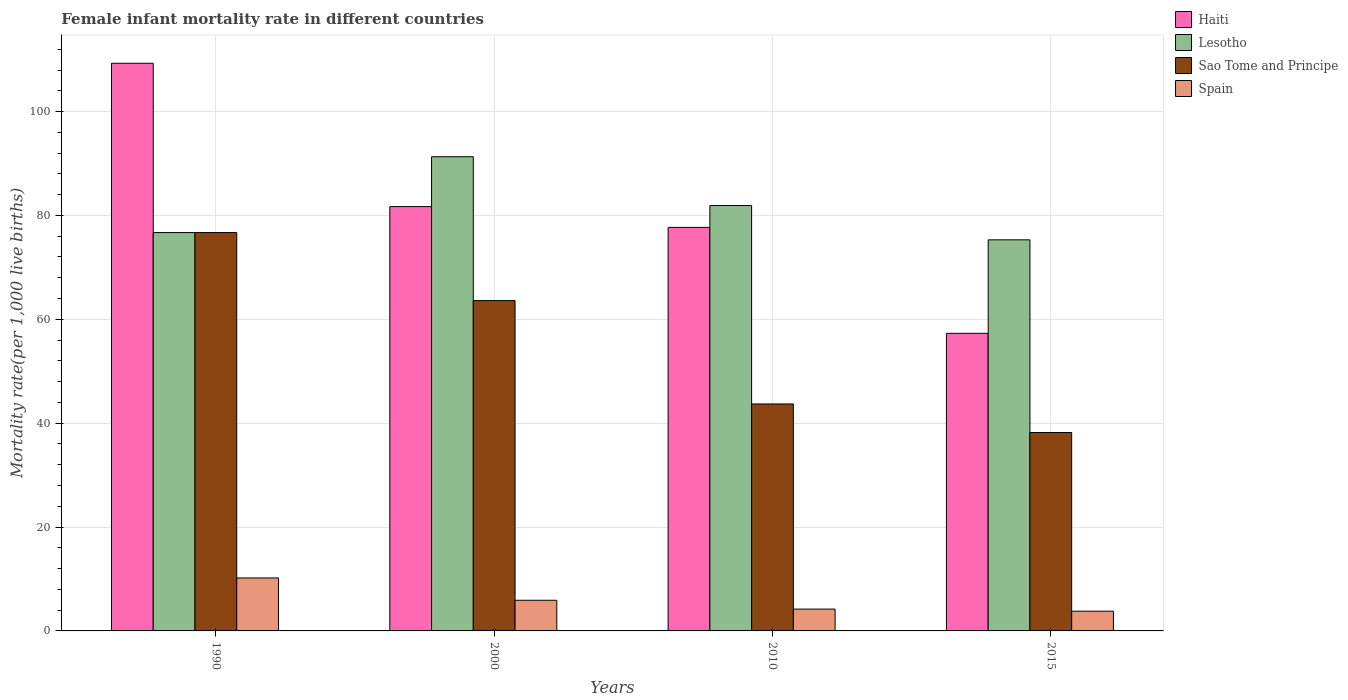How many different coloured bars are there?
Make the answer very short. 4. Are the number of bars on each tick of the X-axis equal?
Provide a succinct answer. Yes. In how many cases, is the number of bars for a given year not equal to the number of legend labels?
Provide a short and direct response. 0. What is the female infant mortality rate in Spain in 2000?
Your answer should be compact. 5.9. Across all years, what is the maximum female infant mortality rate in Haiti?
Offer a terse response. 109.3. Across all years, what is the minimum female infant mortality rate in Spain?
Provide a succinct answer. 3.8. In which year was the female infant mortality rate in Sao Tome and Principe maximum?
Keep it short and to the point. 1990. In which year was the female infant mortality rate in Lesotho minimum?
Provide a short and direct response. 2015. What is the total female infant mortality rate in Lesotho in the graph?
Offer a very short reply. 325.2. What is the difference between the female infant mortality rate in Lesotho in 2000 and that in 2015?
Offer a very short reply. 16. What is the difference between the female infant mortality rate in Spain in 2010 and the female infant mortality rate in Sao Tome and Principe in 2015?
Make the answer very short. -34. What is the average female infant mortality rate in Sao Tome and Principe per year?
Ensure brevity in your answer.  55.55. In the year 2000, what is the difference between the female infant mortality rate in Lesotho and female infant mortality rate in Spain?
Your response must be concise. 85.4. In how many years, is the female infant mortality rate in Spain greater than 60?
Provide a short and direct response. 0. What is the ratio of the female infant mortality rate in Haiti in 1990 to that in 2000?
Your response must be concise. 1.34. Is the difference between the female infant mortality rate in Lesotho in 1990 and 2010 greater than the difference between the female infant mortality rate in Spain in 1990 and 2010?
Your answer should be very brief. No. What is the difference between the highest and the second highest female infant mortality rate in Haiti?
Offer a terse response. 27.6. What is the difference between the highest and the lowest female infant mortality rate in Sao Tome and Principe?
Your response must be concise. 38.5. In how many years, is the female infant mortality rate in Sao Tome and Principe greater than the average female infant mortality rate in Sao Tome and Principe taken over all years?
Your response must be concise. 2. Is the sum of the female infant mortality rate in Haiti in 2000 and 2010 greater than the maximum female infant mortality rate in Sao Tome and Principe across all years?
Give a very brief answer. Yes. Is it the case that in every year, the sum of the female infant mortality rate in Spain and female infant mortality rate in Haiti is greater than the sum of female infant mortality rate in Sao Tome and Principe and female infant mortality rate in Lesotho?
Your answer should be very brief. Yes. What does the 3rd bar from the left in 2000 represents?
Offer a terse response. Sao Tome and Principe. What does the 2nd bar from the right in 2015 represents?
Ensure brevity in your answer.  Sao Tome and Principe. Are all the bars in the graph horizontal?
Provide a succinct answer. No. What is the difference between two consecutive major ticks on the Y-axis?
Your answer should be compact. 20. Does the graph contain grids?
Offer a very short reply. Yes. Where does the legend appear in the graph?
Offer a terse response. Top right. How many legend labels are there?
Keep it short and to the point. 4. How are the legend labels stacked?
Offer a terse response. Vertical. What is the title of the graph?
Provide a succinct answer. Female infant mortality rate in different countries. What is the label or title of the Y-axis?
Keep it short and to the point. Mortality rate(per 1,0 live births). What is the Mortality rate(per 1,000 live births) in Haiti in 1990?
Keep it short and to the point. 109.3. What is the Mortality rate(per 1,000 live births) in Lesotho in 1990?
Provide a short and direct response. 76.7. What is the Mortality rate(per 1,000 live births) in Sao Tome and Principe in 1990?
Provide a succinct answer. 76.7. What is the Mortality rate(per 1,000 live births) in Haiti in 2000?
Provide a succinct answer. 81.7. What is the Mortality rate(per 1,000 live births) of Lesotho in 2000?
Offer a very short reply. 91.3. What is the Mortality rate(per 1,000 live births) in Sao Tome and Principe in 2000?
Your response must be concise. 63.6. What is the Mortality rate(per 1,000 live births) in Haiti in 2010?
Your response must be concise. 77.7. What is the Mortality rate(per 1,000 live births) in Lesotho in 2010?
Give a very brief answer. 81.9. What is the Mortality rate(per 1,000 live births) of Sao Tome and Principe in 2010?
Keep it short and to the point. 43.7. What is the Mortality rate(per 1,000 live births) in Haiti in 2015?
Make the answer very short. 57.3. What is the Mortality rate(per 1,000 live births) in Lesotho in 2015?
Make the answer very short. 75.3. What is the Mortality rate(per 1,000 live births) in Sao Tome and Principe in 2015?
Offer a very short reply. 38.2. Across all years, what is the maximum Mortality rate(per 1,000 live births) in Haiti?
Offer a very short reply. 109.3. Across all years, what is the maximum Mortality rate(per 1,000 live births) of Lesotho?
Give a very brief answer. 91.3. Across all years, what is the maximum Mortality rate(per 1,000 live births) in Sao Tome and Principe?
Your answer should be compact. 76.7. Across all years, what is the minimum Mortality rate(per 1,000 live births) in Haiti?
Your answer should be compact. 57.3. Across all years, what is the minimum Mortality rate(per 1,000 live births) of Lesotho?
Give a very brief answer. 75.3. Across all years, what is the minimum Mortality rate(per 1,000 live births) of Sao Tome and Principe?
Your answer should be very brief. 38.2. Across all years, what is the minimum Mortality rate(per 1,000 live births) in Spain?
Your response must be concise. 3.8. What is the total Mortality rate(per 1,000 live births) of Haiti in the graph?
Your answer should be compact. 326. What is the total Mortality rate(per 1,000 live births) of Lesotho in the graph?
Give a very brief answer. 325.2. What is the total Mortality rate(per 1,000 live births) of Sao Tome and Principe in the graph?
Your answer should be compact. 222.2. What is the total Mortality rate(per 1,000 live births) of Spain in the graph?
Your response must be concise. 24.1. What is the difference between the Mortality rate(per 1,000 live births) in Haiti in 1990 and that in 2000?
Offer a terse response. 27.6. What is the difference between the Mortality rate(per 1,000 live births) in Lesotho in 1990 and that in 2000?
Your answer should be very brief. -14.6. What is the difference between the Mortality rate(per 1,000 live births) of Spain in 1990 and that in 2000?
Offer a terse response. 4.3. What is the difference between the Mortality rate(per 1,000 live births) of Haiti in 1990 and that in 2010?
Provide a short and direct response. 31.6. What is the difference between the Mortality rate(per 1,000 live births) in Lesotho in 1990 and that in 2010?
Give a very brief answer. -5.2. What is the difference between the Mortality rate(per 1,000 live births) in Sao Tome and Principe in 1990 and that in 2010?
Offer a very short reply. 33. What is the difference between the Mortality rate(per 1,000 live births) in Spain in 1990 and that in 2010?
Provide a succinct answer. 6. What is the difference between the Mortality rate(per 1,000 live births) in Haiti in 1990 and that in 2015?
Ensure brevity in your answer.  52. What is the difference between the Mortality rate(per 1,000 live births) of Lesotho in 1990 and that in 2015?
Make the answer very short. 1.4. What is the difference between the Mortality rate(per 1,000 live births) in Sao Tome and Principe in 1990 and that in 2015?
Provide a short and direct response. 38.5. What is the difference between the Mortality rate(per 1,000 live births) of Haiti in 2000 and that in 2010?
Your response must be concise. 4. What is the difference between the Mortality rate(per 1,000 live births) in Lesotho in 2000 and that in 2010?
Give a very brief answer. 9.4. What is the difference between the Mortality rate(per 1,000 live births) of Sao Tome and Principe in 2000 and that in 2010?
Provide a short and direct response. 19.9. What is the difference between the Mortality rate(per 1,000 live births) in Spain in 2000 and that in 2010?
Your answer should be compact. 1.7. What is the difference between the Mortality rate(per 1,000 live births) of Haiti in 2000 and that in 2015?
Provide a short and direct response. 24.4. What is the difference between the Mortality rate(per 1,000 live births) of Sao Tome and Principe in 2000 and that in 2015?
Give a very brief answer. 25.4. What is the difference between the Mortality rate(per 1,000 live births) in Haiti in 2010 and that in 2015?
Offer a very short reply. 20.4. What is the difference between the Mortality rate(per 1,000 live births) of Sao Tome and Principe in 2010 and that in 2015?
Provide a succinct answer. 5.5. What is the difference between the Mortality rate(per 1,000 live births) of Spain in 2010 and that in 2015?
Keep it short and to the point. 0.4. What is the difference between the Mortality rate(per 1,000 live births) of Haiti in 1990 and the Mortality rate(per 1,000 live births) of Sao Tome and Principe in 2000?
Your response must be concise. 45.7. What is the difference between the Mortality rate(per 1,000 live births) in Haiti in 1990 and the Mortality rate(per 1,000 live births) in Spain in 2000?
Offer a very short reply. 103.4. What is the difference between the Mortality rate(per 1,000 live births) in Lesotho in 1990 and the Mortality rate(per 1,000 live births) in Sao Tome and Principe in 2000?
Provide a short and direct response. 13.1. What is the difference between the Mortality rate(per 1,000 live births) in Lesotho in 1990 and the Mortality rate(per 1,000 live births) in Spain in 2000?
Offer a terse response. 70.8. What is the difference between the Mortality rate(per 1,000 live births) of Sao Tome and Principe in 1990 and the Mortality rate(per 1,000 live births) of Spain in 2000?
Make the answer very short. 70.8. What is the difference between the Mortality rate(per 1,000 live births) of Haiti in 1990 and the Mortality rate(per 1,000 live births) of Lesotho in 2010?
Your answer should be compact. 27.4. What is the difference between the Mortality rate(per 1,000 live births) in Haiti in 1990 and the Mortality rate(per 1,000 live births) in Sao Tome and Principe in 2010?
Your answer should be very brief. 65.6. What is the difference between the Mortality rate(per 1,000 live births) in Haiti in 1990 and the Mortality rate(per 1,000 live births) in Spain in 2010?
Offer a very short reply. 105.1. What is the difference between the Mortality rate(per 1,000 live births) of Lesotho in 1990 and the Mortality rate(per 1,000 live births) of Spain in 2010?
Offer a terse response. 72.5. What is the difference between the Mortality rate(per 1,000 live births) in Sao Tome and Principe in 1990 and the Mortality rate(per 1,000 live births) in Spain in 2010?
Offer a very short reply. 72.5. What is the difference between the Mortality rate(per 1,000 live births) of Haiti in 1990 and the Mortality rate(per 1,000 live births) of Lesotho in 2015?
Your answer should be very brief. 34. What is the difference between the Mortality rate(per 1,000 live births) in Haiti in 1990 and the Mortality rate(per 1,000 live births) in Sao Tome and Principe in 2015?
Offer a terse response. 71.1. What is the difference between the Mortality rate(per 1,000 live births) of Haiti in 1990 and the Mortality rate(per 1,000 live births) of Spain in 2015?
Provide a succinct answer. 105.5. What is the difference between the Mortality rate(per 1,000 live births) in Lesotho in 1990 and the Mortality rate(per 1,000 live births) in Sao Tome and Principe in 2015?
Offer a terse response. 38.5. What is the difference between the Mortality rate(per 1,000 live births) of Lesotho in 1990 and the Mortality rate(per 1,000 live births) of Spain in 2015?
Offer a terse response. 72.9. What is the difference between the Mortality rate(per 1,000 live births) in Sao Tome and Principe in 1990 and the Mortality rate(per 1,000 live births) in Spain in 2015?
Provide a succinct answer. 72.9. What is the difference between the Mortality rate(per 1,000 live births) in Haiti in 2000 and the Mortality rate(per 1,000 live births) in Spain in 2010?
Keep it short and to the point. 77.5. What is the difference between the Mortality rate(per 1,000 live births) of Lesotho in 2000 and the Mortality rate(per 1,000 live births) of Sao Tome and Principe in 2010?
Your response must be concise. 47.6. What is the difference between the Mortality rate(per 1,000 live births) in Lesotho in 2000 and the Mortality rate(per 1,000 live births) in Spain in 2010?
Your answer should be compact. 87.1. What is the difference between the Mortality rate(per 1,000 live births) in Sao Tome and Principe in 2000 and the Mortality rate(per 1,000 live births) in Spain in 2010?
Offer a terse response. 59.4. What is the difference between the Mortality rate(per 1,000 live births) of Haiti in 2000 and the Mortality rate(per 1,000 live births) of Lesotho in 2015?
Your answer should be compact. 6.4. What is the difference between the Mortality rate(per 1,000 live births) of Haiti in 2000 and the Mortality rate(per 1,000 live births) of Sao Tome and Principe in 2015?
Ensure brevity in your answer.  43.5. What is the difference between the Mortality rate(per 1,000 live births) of Haiti in 2000 and the Mortality rate(per 1,000 live births) of Spain in 2015?
Provide a succinct answer. 77.9. What is the difference between the Mortality rate(per 1,000 live births) in Lesotho in 2000 and the Mortality rate(per 1,000 live births) in Sao Tome and Principe in 2015?
Offer a very short reply. 53.1. What is the difference between the Mortality rate(per 1,000 live births) of Lesotho in 2000 and the Mortality rate(per 1,000 live births) of Spain in 2015?
Keep it short and to the point. 87.5. What is the difference between the Mortality rate(per 1,000 live births) of Sao Tome and Principe in 2000 and the Mortality rate(per 1,000 live births) of Spain in 2015?
Your answer should be compact. 59.8. What is the difference between the Mortality rate(per 1,000 live births) in Haiti in 2010 and the Mortality rate(per 1,000 live births) in Lesotho in 2015?
Offer a terse response. 2.4. What is the difference between the Mortality rate(per 1,000 live births) of Haiti in 2010 and the Mortality rate(per 1,000 live births) of Sao Tome and Principe in 2015?
Provide a succinct answer. 39.5. What is the difference between the Mortality rate(per 1,000 live births) in Haiti in 2010 and the Mortality rate(per 1,000 live births) in Spain in 2015?
Your answer should be very brief. 73.9. What is the difference between the Mortality rate(per 1,000 live births) in Lesotho in 2010 and the Mortality rate(per 1,000 live births) in Sao Tome and Principe in 2015?
Give a very brief answer. 43.7. What is the difference between the Mortality rate(per 1,000 live births) of Lesotho in 2010 and the Mortality rate(per 1,000 live births) of Spain in 2015?
Give a very brief answer. 78.1. What is the difference between the Mortality rate(per 1,000 live births) of Sao Tome and Principe in 2010 and the Mortality rate(per 1,000 live births) of Spain in 2015?
Provide a succinct answer. 39.9. What is the average Mortality rate(per 1,000 live births) in Haiti per year?
Keep it short and to the point. 81.5. What is the average Mortality rate(per 1,000 live births) of Lesotho per year?
Your answer should be compact. 81.3. What is the average Mortality rate(per 1,000 live births) of Sao Tome and Principe per year?
Ensure brevity in your answer.  55.55. What is the average Mortality rate(per 1,000 live births) in Spain per year?
Offer a terse response. 6.03. In the year 1990, what is the difference between the Mortality rate(per 1,000 live births) of Haiti and Mortality rate(per 1,000 live births) of Lesotho?
Your answer should be compact. 32.6. In the year 1990, what is the difference between the Mortality rate(per 1,000 live births) in Haiti and Mortality rate(per 1,000 live births) in Sao Tome and Principe?
Your answer should be very brief. 32.6. In the year 1990, what is the difference between the Mortality rate(per 1,000 live births) of Haiti and Mortality rate(per 1,000 live births) of Spain?
Your answer should be very brief. 99.1. In the year 1990, what is the difference between the Mortality rate(per 1,000 live births) of Lesotho and Mortality rate(per 1,000 live births) of Sao Tome and Principe?
Offer a terse response. 0. In the year 1990, what is the difference between the Mortality rate(per 1,000 live births) of Lesotho and Mortality rate(per 1,000 live births) of Spain?
Keep it short and to the point. 66.5. In the year 1990, what is the difference between the Mortality rate(per 1,000 live births) in Sao Tome and Principe and Mortality rate(per 1,000 live births) in Spain?
Provide a succinct answer. 66.5. In the year 2000, what is the difference between the Mortality rate(per 1,000 live births) of Haiti and Mortality rate(per 1,000 live births) of Lesotho?
Offer a terse response. -9.6. In the year 2000, what is the difference between the Mortality rate(per 1,000 live births) in Haiti and Mortality rate(per 1,000 live births) in Spain?
Keep it short and to the point. 75.8. In the year 2000, what is the difference between the Mortality rate(per 1,000 live births) of Lesotho and Mortality rate(per 1,000 live births) of Sao Tome and Principe?
Your answer should be compact. 27.7. In the year 2000, what is the difference between the Mortality rate(per 1,000 live births) in Lesotho and Mortality rate(per 1,000 live births) in Spain?
Provide a succinct answer. 85.4. In the year 2000, what is the difference between the Mortality rate(per 1,000 live births) in Sao Tome and Principe and Mortality rate(per 1,000 live births) in Spain?
Offer a terse response. 57.7. In the year 2010, what is the difference between the Mortality rate(per 1,000 live births) of Haiti and Mortality rate(per 1,000 live births) of Lesotho?
Make the answer very short. -4.2. In the year 2010, what is the difference between the Mortality rate(per 1,000 live births) in Haiti and Mortality rate(per 1,000 live births) in Sao Tome and Principe?
Ensure brevity in your answer.  34. In the year 2010, what is the difference between the Mortality rate(per 1,000 live births) of Haiti and Mortality rate(per 1,000 live births) of Spain?
Offer a terse response. 73.5. In the year 2010, what is the difference between the Mortality rate(per 1,000 live births) in Lesotho and Mortality rate(per 1,000 live births) in Sao Tome and Principe?
Keep it short and to the point. 38.2. In the year 2010, what is the difference between the Mortality rate(per 1,000 live births) in Lesotho and Mortality rate(per 1,000 live births) in Spain?
Make the answer very short. 77.7. In the year 2010, what is the difference between the Mortality rate(per 1,000 live births) of Sao Tome and Principe and Mortality rate(per 1,000 live births) of Spain?
Your answer should be very brief. 39.5. In the year 2015, what is the difference between the Mortality rate(per 1,000 live births) of Haiti and Mortality rate(per 1,000 live births) of Sao Tome and Principe?
Give a very brief answer. 19.1. In the year 2015, what is the difference between the Mortality rate(per 1,000 live births) of Haiti and Mortality rate(per 1,000 live births) of Spain?
Make the answer very short. 53.5. In the year 2015, what is the difference between the Mortality rate(per 1,000 live births) of Lesotho and Mortality rate(per 1,000 live births) of Sao Tome and Principe?
Your response must be concise. 37.1. In the year 2015, what is the difference between the Mortality rate(per 1,000 live births) of Lesotho and Mortality rate(per 1,000 live births) of Spain?
Make the answer very short. 71.5. In the year 2015, what is the difference between the Mortality rate(per 1,000 live births) of Sao Tome and Principe and Mortality rate(per 1,000 live births) of Spain?
Provide a succinct answer. 34.4. What is the ratio of the Mortality rate(per 1,000 live births) in Haiti in 1990 to that in 2000?
Give a very brief answer. 1.34. What is the ratio of the Mortality rate(per 1,000 live births) in Lesotho in 1990 to that in 2000?
Your answer should be compact. 0.84. What is the ratio of the Mortality rate(per 1,000 live births) of Sao Tome and Principe in 1990 to that in 2000?
Your answer should be compact. 1.21. What is the ratio of the Mortality rate(per 1,000 live births) in Spain in 1990 to that in 2000?
Give a very brief answer. 1.73. What is the ratio of the Mortality rate(per 1,000 live births) in Haiti in 1990 to that in 2010?
Your answer should be compact. 1.41. What is the ratio of the Mortality rate(per 1,000 live births) of Lesotho in 1990 to that in 2010?
Ensure brevity in your answer.  0.94. What is the ratio of the Mortality rate(per 1,000 live births) of Sao Tome and Principe in 1990 to that in 2010?
Your answer should be very brief. 1.76. What is the ratio of the Mortality rate(per 1,000 live births) of Spain in 1990 to that in 2010?
Your answer should be compact. 2.43. What is the ratio of the Mortality rate(per 1,000 live births) in Haiti in 1990 to that in 2015?
Ensure brevity in your answer.  1.91. What is the ratio of the Mortality rate(per 1,000 live births) of Lesotho in 1990 to that in 2015?
Your answer should be compact. 1.02. What is the ratio of the Mortality rate(per 1,000 live births) in Sao Tome and Principe in 1990 to that in 2015?
Keep it short and to the point. 2.01. What is the ratio of the Mortality rate(per 1,000 live births) of Spain in 1990 to that in 2015?
Provide a succinct answer. 2.68. What is the ratio of the Mortality rate(per 1,000 live births) in Haiti in 2000 to that in 2010?
Provide a succinct answer. 1.05. What is the ratio of the Mortality rate(per 1,000 live births) of Lesotho in 2000 to that in 2010?
Provide a succinct answer. 1.11. What is the ratio of the Mortality rate(per 1,000 live births) of Sao Tome and Principe in 2000 to that in 2010?
Provide a short and direct response. 1.46. What is the ratio of the Mortality rate(per 1,000 live births) in Spain in 2000 to that in 2010?
Your answer should be compact. 1.4. What is the ratio of the Mortality rate(per 1,000 live births) in Haiti in 2000 to that in 2015?
Offer a very short reply. 1.43. What is the ratio of the Mortality rate(per 1,000 live births) of Lesotho in 2000 to that in 2015?
Make the answer very short. 1.21. What is the ratio of the Mortality rate(per 1,000 live births) in Sao Tome and Principe in 2000 to that in 2015?
Your response must be concise. 1.66. What is the ratio of the Mortality rate(per 1,000 live births) of Spain in 2000 to that in 2015?
Make the answer very short. 1.55. What is the ratio of the Mortality rate(per 1,000 live births) of Haiti in 2010 to that in 2015?
Make the answer very short. 1.36. What is the ratio of the Mortality rate(per 1,000 live births) in Lesotho in 2010 to that in 2015?
Your response must be concise. 1.09. What is the ratio of the Mortality rate(per 1,000 live births) in Sao Tome and Principe in 2010 to that in 2015?
Provide a short and direct response. 1.14. What is the ratio of the Mortality rate(per 1,000 live births) in Spain in 2010 to that in 2015?
Your answer should be compact. 1.11. What is the difference between the highest and the second highest Mortality rate(per 1,000 live births) of Haiti?
Keep it short and to the point. 27.6. What is the difference between the highest and the second highest Mortality rate(per 1,000 live births) in Lesotho?
Your answer should be compact. 9.4. What is the difference between the highest and the second highest Mortality rate(per 1,000 live births) in Sao Tome and Principe?
Keep it short and to the point. 13.1. What is the difference between the highest and the second highest Mortality rate(per 1,000 live births) of Spain?
Ensure brevity in your answer.  4.3. What is the difference between the highest and the lowest Mortality rate(per 1,000 live births) of Lesotho?
Your response must be concise. 16. What is the difference between the highest and the lowest Mortality rate(per 1,000 live births) of Sao Tome and Principe?
Your answer should be compact. 38.5. What is the difference between the highest and the lowest Mortality rate(per 1,000 live births) in Spain?
Your response must be concise. 6.4. 